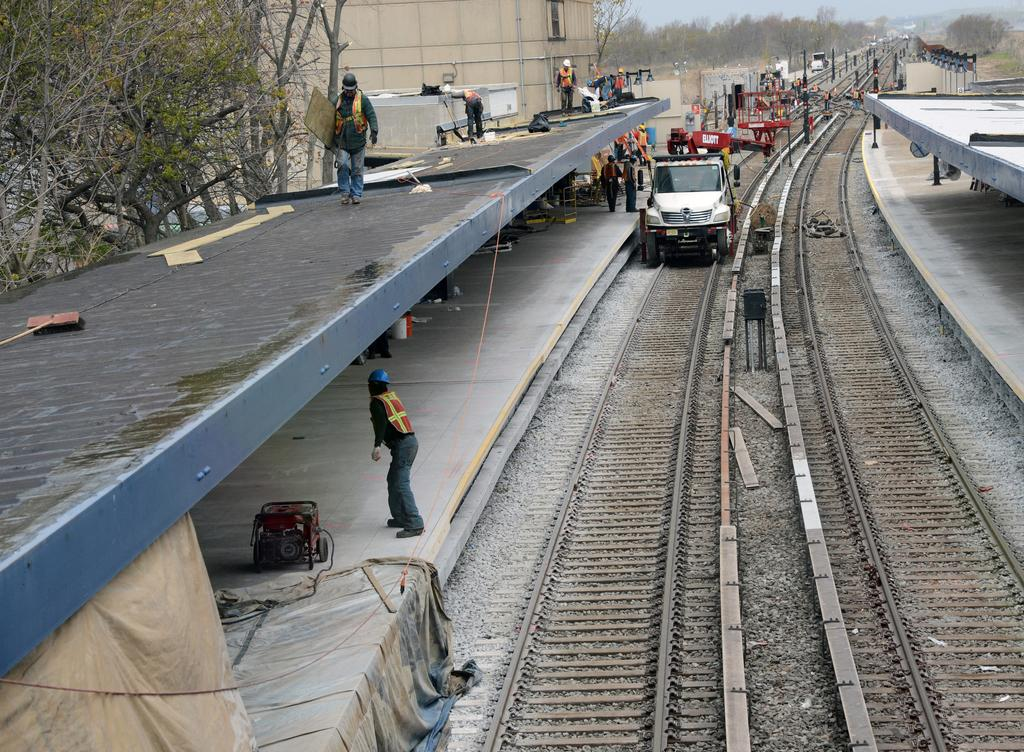What is on the train track in the image? There is a vehicle on the train track in the image. Who or what is near the vehicle? There are people around the vehicle in the image. What can be seen in the background of the image? There are trees visible in the image. What is on the floor in the image? There is cloth on the floor in the image. What type of science experiment is being conducted with the fork in the image? There is no fork present in the image, and therefore no science experiment can be observed. 